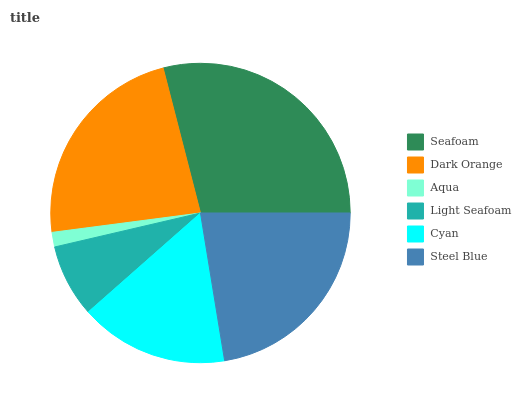Is Aqua the minimum?
Answer yes or no. Yes. Is Seafoam the maximum?
Answer yes or no. Yes. Is Dark Orange the minimum?
Answer yes or no. No. Is Dark Orange the maximum?
Answer yes or no. No. Is Seafoam greater than Dark Orange?
Answer yes or no. Yes. Is Dark Orange less than Seafoam?
Answer yes or no. Yes. Is Dark Orange greater than Seafoam?
Answer yes or no. No. Is Seafoam less than Dark Orange?
Answer yes or no. No. Is Steel Blue the high median?
Answer yes or no. Yes. Is Cyan the low median?
Answer yes or no. Yes. Is Dark Orange the high median?
Answer yes or no. No. Is Steel Blue the low median?
Answer yes or no. No. 